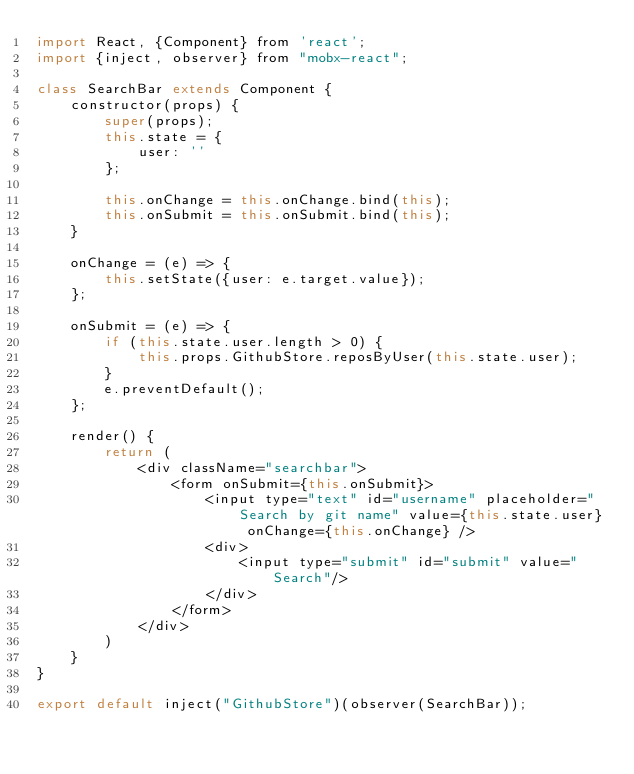Convert code to text. <code><loc_0><loc_0><loc_500><loc_500><_JavaScript_>import React, {Component} from 'react';
import {inject, observer} from "mobx-react";

class SearchBar extends Component {
    constructor(props) {
        super(props);
        this.state = {
            user: ''
        };

        this.onChange = this.onChange.bind(this);
        this.onSubmit = this.onSubmit.bind(this);
    }

    onChange = (e) => {
        this.setState({user: e.target.value});
    };

    onSubmit = (e) => {
        if (this.state.user.length > 0) {
            this.props.GithubStore.reposByUser(this.state.user);
        }
        e.preventDefault();
    };

    render() {
        return (
            <div className="searchbar">
                <form onSubmit={this.onSubmit}>
                    <input type="text" id="username" placeholder="Search by git name" value={this.state.user} onChange={this.onChange} />
                    <div>
                        <input type="submit" id="submit" value="Search"/>
                    </div>
                </form>
            </div>
        )
    }
}

export default inject("GithubStore")(observer(SearchBar));
</code> 